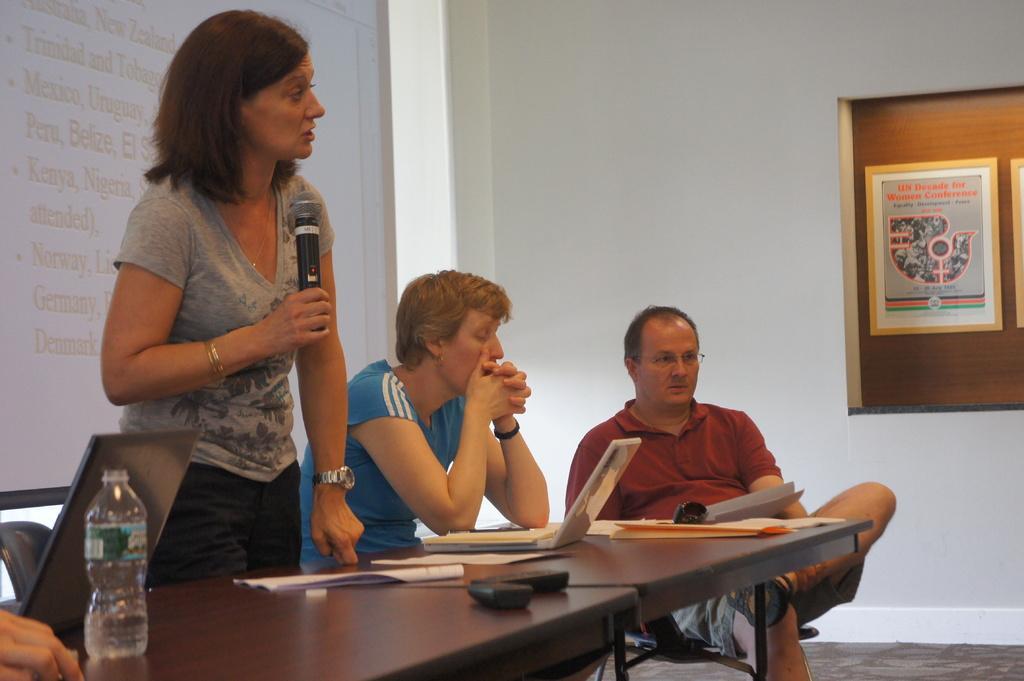Can you describe this image briefly? This image is taken in a meeting room. There are three persons in this room. In the background there is a projector screen with a text. In the left side of the image there is a table which has laptop, remote, water bottle, papers and a book. In the middle of the image a man who is sitting on a chair wearing a spectacles. In the background there is a wall which has a frame. In the middle of the image a woman is standing with holding a mic. There is a chair, there is a floor mat. 